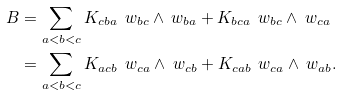<formula> <loc_0><loc_0><loc_500><loc_500>B & = \sum _ { a < b < c } K _ { c b a } \, \ w _ { b c } \wedge \ w _ { b a } + K _ { b c a } \, \ w _ { b c } \wedge \ w _ { c a } \\ & = \sum _ { a < b < c } K _ { a c b } \, \ w _ { c a } \wedge \ w _ { c b } + K _ { c a b } \, \ w _ { c a } \wedge \ w _ { a b } .</formula> 